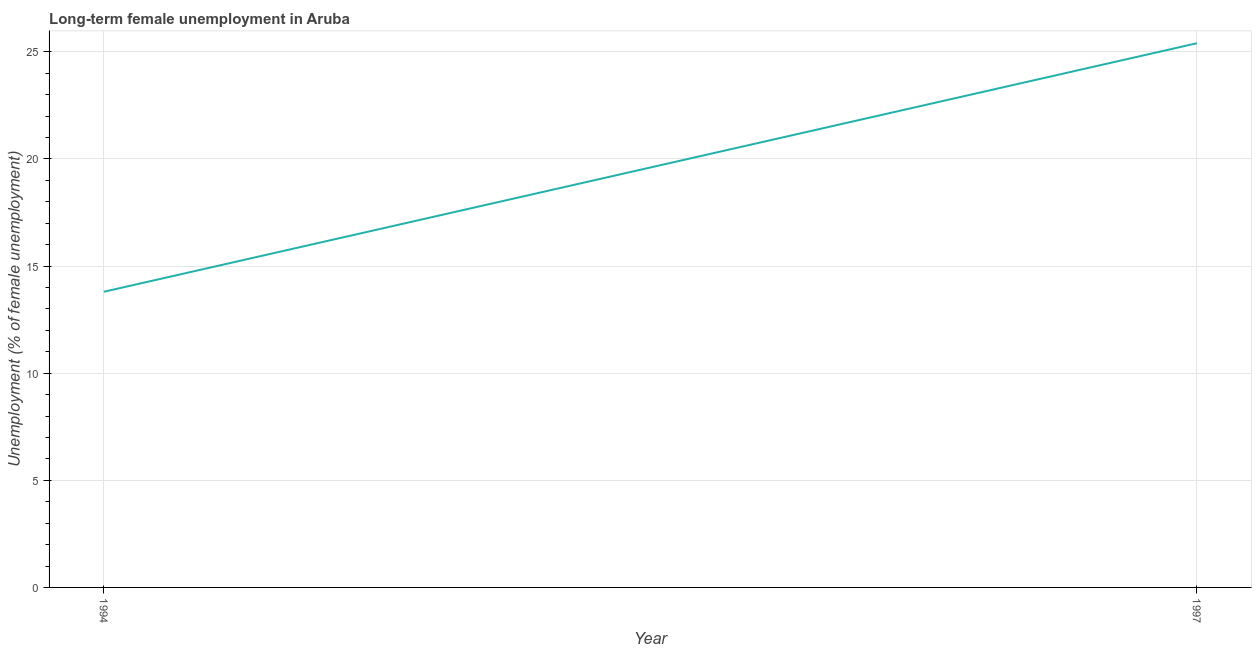What is the long-term female unemployment in 1994?
Make the answer very short. 13.8. Across all years, what is the maximum long-term female unemployment?
Offer a very short reply. 25.4. Across all years, what is the minimum long-term female unemployment?
Your response must be concise. 13.8. In which year was the long-term female unemployment minimum?
Provide a succinct answer. 1994. What is the sum of the long-term female unemployment?
Offer a very short reply. 39.2. What is the difference between the long-term female unemployment in 1994 and 1997?
Your answer should be compact. -11.6. What is the average long-term female unemployment per year?
Provide a succinct answer. 19.6. What is the median long-term female unemployment?
Keep it short and to the point. 19.6. In how many years, is the long-term female unemployment greater than 18 %?
Your response must be concise. 1. What is the ratio of the long-term female unemployment in 1994 to that in 1997?
Make the answer very short. 0.54. Is the long-term female unemployment in 1994 less than that in 1997?
Provide a short and direct response. Yes. In how many years, is the long-term female unemployment greater than the average long-term female unemployment taken over all years?
Ensure brevity in your answer.  1. How many lines are there?
Provide a succinct answer. 1. How many years are there in the graph?
Provide a succinct answer. 2. What is the difference between two consecutive major ticks on the Y-axis?
Offer a terse response. 5. Does the graph contain any zero values?
Your answer should be compact. No. Does the graph contain grids?
Offer a terse response. Yes. What is the title of the graph?
Make the answer very short. Long-term female unemployment in Aruba. What is the label or title of the Y-axis?
Provide a succinct answer. Unemployment (% of female unemployment). What is the Unemployment (% of female unemployment) in 1994?
Offer a very short reply. 13.8. What is the Unemployment (% of female unemployment) of 1997?
Your answer should be very brief. 25.4. What is the ratio of the Unemployment (% of female unemployment) in 1994 to that in 1997?
Provide a short and direct response. 0.54. 